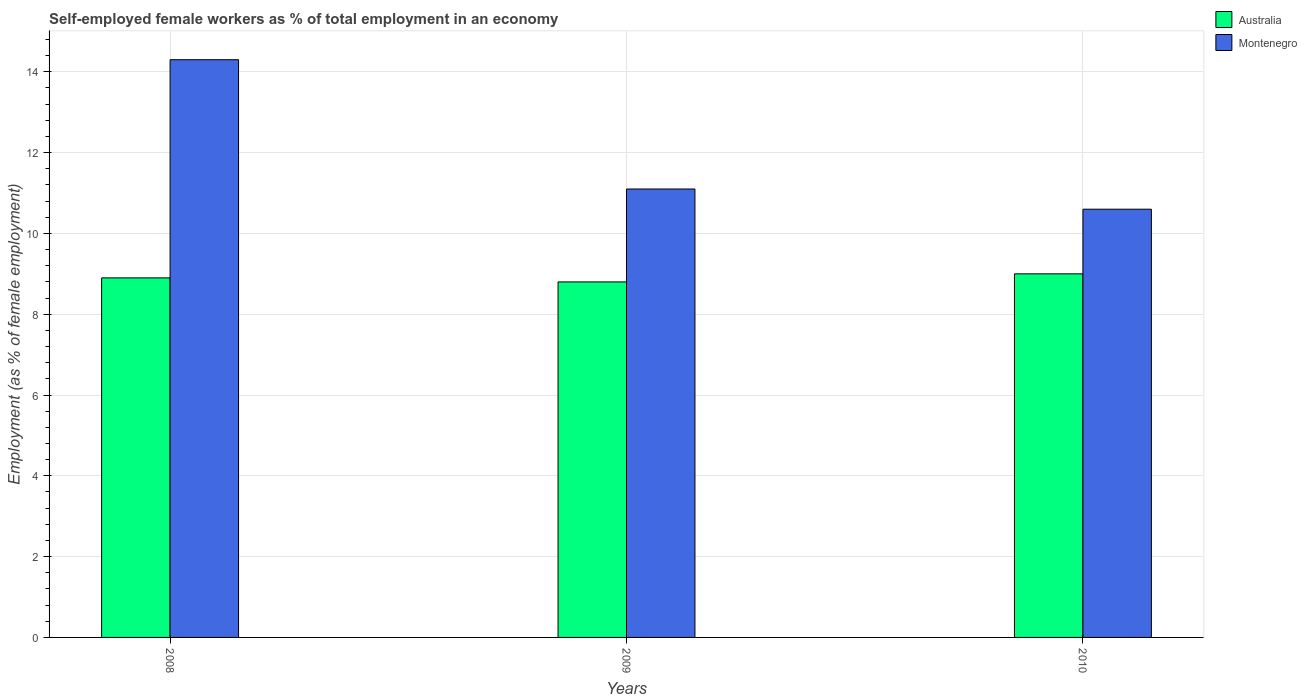How many different coloured bars are there?
Provide a short and direct response. 2. How many groups of bars are there?
Ensure brevity in your answer.  3. Are the number of bars per tick equal to the number of legend labels?
Your answer should be very brief. Yes. Are the number of bars on each tick of the X-axis equal?
Offer a very short reply. Yes. What is the label of the 1st group of bars from the left?
Your answer should be very brief. 2008. In how many cases, is the number of bars for a given year not equal to the number of legend labels?
Provide a short and direct response. 0. What is the percentage of self-employed female workers in Montenegro in 2010?
Your answer should be compact. 10.6. Across all years, what is the maximum percentage of self-employed female workers in Montenegro?
Give a very brief answer. 14.3. Across all years, what is the minimum percentage of self-employed female workers in Montenegro?
Offer a very short reply. 10.6. What is the total percentage of self-employed female workers in Montenegro in the graph?
Your response must be concise. 36. What is the difference between the percentage of self-employed female workers in Australia in 2008 and the percentage of self-employed female workers in Montenegro in 2009?
Offer a terse response. -2.2. What is the average percentage of self-employed female workers in Montenegro per year?
Make the answer very short. 12. In the year 2010, what is the difference between the percentage of self-employed female workers in Montenegro and percentage of self-employed female workers in Australia?
Offer a very short reply. 1.6. What is the ratio of the percentage of self-employed female workers in Montenegro in 2008 to that in 2009?
Offer a very short reply. 1.29. Is the difference between the percentage of self-employed female workers in Montenegro in 2008 and 2010 greater than the difference between the percentage of self-employed female workers in Australia in 2008 and 2010?
Your answer should be compact. Yes. What is the difference between the highest and the second highest percentage of self-employed female workers in Australia?
Your answer should be compact. 0.1. What is the difference between the highest and the lowest percentage of self-employed female workers in Montenegro?
Give a very brief answer. 3.7. What does the 1st bar from the right in 2009 represents?
Your answer should be very brief. Montenegro. How many bars are there?
Offer a very short reply. 6. Are all the bars in the graph horizontal?
Keep it short and to the point. No. How many years are there in the graph?
Provide a succinct answer. 3. Are the values on the major ticks of Y-axis written in scientific E-notation?
Offer a very short reply. No. How many legend labels are there?
Provide a succinct answer. 2. What is the title of the graph?
Ensure brevity in your answer.  Self-employed female workers as % of total employment in an economy. What is the label or title of the X-axis?
Your answer should be compact. Years. What is the label or title of the Y-axis?
Give a very brief answer. Employment (as % of female employment). What is the Employment (as % of female employment) in Australia in 2008?
Your answer should be compact. 8.9. What is the Employment (as % of female employment) in Montenegro in 2008?
Keep it short and to the point. 14.3. What is the Employment (as % of female employment) of Australia in 2009?
Provide a short and direct response. 8.8. What is the Employment (as % of female employment) in Montenegro in 2009?
Provide a short and direct response. 11.1. What is the Employment (as % of female employment) in Montenegro in 2010?
Keep it short and to the point. 10.6. Across all years, what is the maximum Employment (as % of female employment) in Montenegro?
Your answer should be very brief. 14.3. Across all years, what is the minimum Employment (as % of female employment) of Australia?
Offer a terse response. 8.8. Across all years, what is the minimum Employment (as % of female employment) of Montenegro?
Your response must be concise. 10.6. What is the total Employment (as % of female employment) of Australia in the graph?
Give a very brief answer. 26.7. What is the difference between the Employment (as % of female employment) in Montenegro in 2008 and that in 2009?
Provide a short and direct response. 3.2. What is the difference between the Employment (as % of female employment) in Australia in 2008 and that in 2010?
Your answer should be very brief. -0.1. What is the difference between the Employment (as % of female employment) of Montenegro in 2009 and that in 2010?
Your answer should be compact. 0.5. What is the difference between the Employment (as % of female employment) in Australia in 2008 and the Employment (as % of female employment) in Montenegro in 2009?
Ensure brevity in your answer.  -2.2. What is the difference between the Employment (as % of female employment) in Australia in 2008 and the Employment (as % of female employment) in Montenegro in 2010?
Ensure brevity in your answer.  -1.7. What is the difference between the Employment (as % of female employment) of Australia in 2009 and the Employment (as % of female employment) of Montenegro in 2010?
Ensure brevity in your answer.  -1.8. In the year 2008, what is the difference between the Employment (as % of female employment) of Australia and Employment (as % of female employment) of Montenegro?
Offer a very short reply. -5.4. In the year 2009, what is the difference between the Employment (as % of female employment) of Australia and Employment (as % of female employment) of Montenegro?
Your answer should be compact. -2.3. What is the ratio of the Employment (as % of female employment) in Australia in 2008 to that in 2009?
Ensure brevity in your answer.  1.01. What is the ratio of the Employment (as % of female employment) in Montenegro in 2008 to that in 2009?
Provide a succinct answer. 1.29. What is the ratio of the Employment (as % of female employment) of Australia in 2008 to that in 2010?
Your response must be concise. 0.99. What is the ratio of the Employment (as % of female employment) in Montenegro in 2008 to that in 2010?
Give a very brief answer. 1.35. What is the ratio of the Employment (as % of female employment) in Australia in 2009 to that in 2010?
Provide a succinct answer. 0.98. What is the ratio of the Employment (as % of female employment) of Montenegro in 2009 to that in 2010?
Give a very brief answer. 1.05. What is the difference between the highest and the second highest Employment (as % of female employment) of Australia?
Ensure brevity in your answer.  0.1. What is the difference between the highest and the second highest Employment (as % of female employment) of Montenegro?
Provide a succinct answer. 3.2. What is the difference between the highest and the lowest Employment (as % of female employment) of Australia?
Make the answer very short. 0.2. What is the difference between the highest and the lowest Employment (as % of female employment) of Montenegro?
Provide a short and direct response. 3.7. 